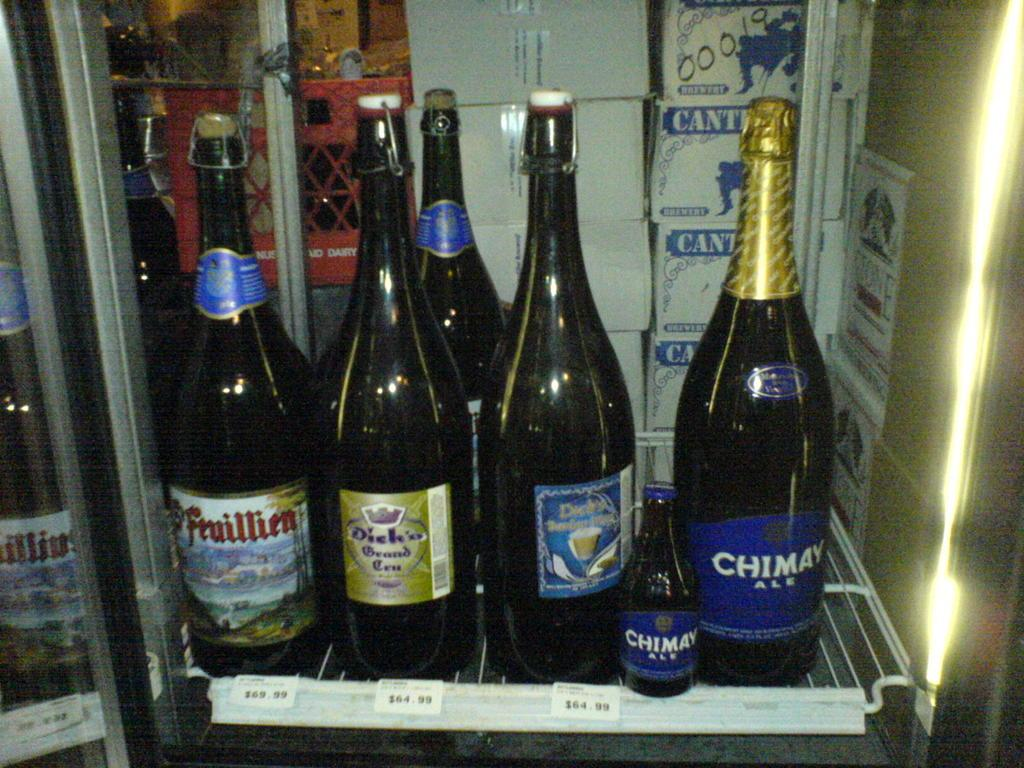<image>
Share a concise interpretation of the image provided. Alcohol in a chilled case at the store that includes Feuillien brand alcohol. 